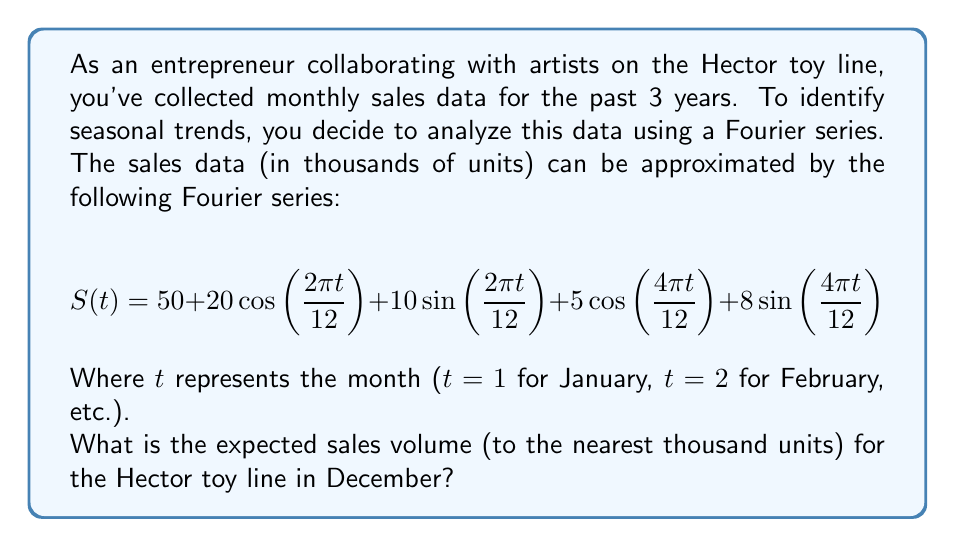Teach me how to tackle this problem. To solve this problem, we need to follow these steps:

1) First, we need to determine the value of $t$ for December. Since December is the 12th month, $t = 12$.

2) Now, we substitute $t = 12$ into the given Fourier series:

   $$S(12) = 50 + 20\cos(\frac{2\pi \cdot 12}{12}) + 10\sin(\frac{2\pi \cdot 12}{12}) + 5\cos(\frac{4\pi \cdot 12}{12}) + 8\sin(\frac{4\pi \cdot 12}{12})$$

3) Simplify the arguments of the trigonometric functions:

   $$S(12) = 50 + 20\cos(2\pi) + 10\sin(2\pi) + 5\cos(4\pi) + 8\sin(4\pi)$$

4) Recall the following trigonometric identities:
   - $\cos(2\pi) = 1$
   - $\sin(2\pi) = 0$
   - $\cos(4\pi) = 1$
   - $\sin(4\pi) = 0$

5) Apply these identities:

   $$S(12) = 50 + 20(1) + 10(0) + 5(1) + 8(0)$$

6) Simplify:

   $$S(12) = 50 + 20 + 5 = 75$$

7) The question asks for the answer to the nearest thousand units. Since 75 represents 75,000 units, we round to 75,000.
Answer: 75,000 units 